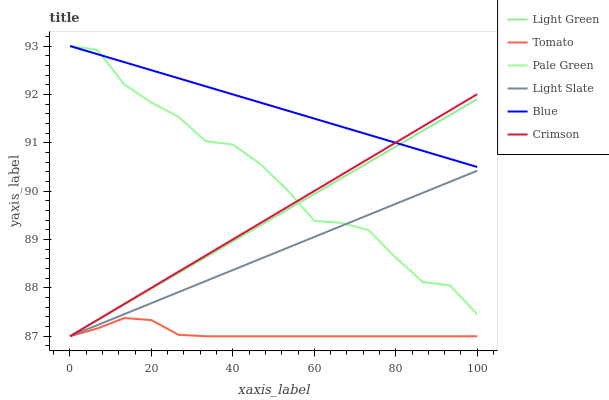Does Tomato have the minimum area under the curve?
Answer yes or no. Yes. Does Blue have the maximum area under the curve?
Answer yes or no. Yes. Does Light Slate have the minimum area under the curve?
Answer yes or no. No. Does Light Slate have the maximum area under the curve?
Answer yes or no. No. Is Blue the smoothest?
Answer yes or no. Yes. Is Pale Green the roughest?
Answer yes or no. Yes. Is Light Slate the smoothest?
Answer yes or no. No. Is Light Slate the roughest?
Answer yes or no. No. Does Tomato have the lowest value?
Answer yes or no. Yes. Does Blue have the lowest value?
Answer yes or no. No. Does Pale Green have the highest value?
Answer yes or no. Yes. Does Light Slate have the highest value?
Answer yes or no. No. Is Tomato less than Blue?
Answer yes or no. Yes. Is Pale Green greater than Tomato?
Answer yes or no. Yes. Does Light Slate intersect Crimson?
Answer yes or no. Yes. Is Light Slate less than Crimson?
Answer yes or no. No. Is Light Slate greater than Crimson?
Answer yes or no. No. Does Tomato intersect Blue?
Answer yes or no. No. 